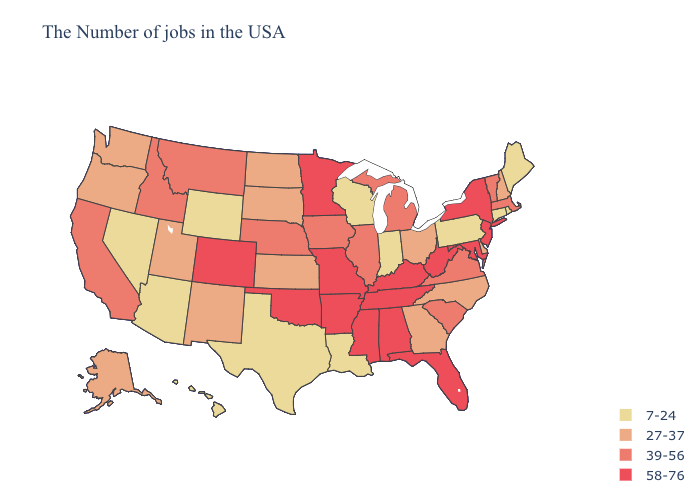Name the states that have a value in the range 27-37?
Answer briefly. New Hampshire, Delaware, North Carolina, Ohio, Georgia, Kansas, South Dakota, North Dakota, New Mexico, Utah, Washington, Oregon, Alaska. Which states hav the highest value in the MidWest?
Be succinct. Missouri, Minnesota. Name the states that have a value in the range 58-76?
Quick response, please. New York, New Jersey, Maryland, West Virginia, Florida, Kentucky, Alabama, Tennessee, Mississippi, Missouri, Arkansas, Minnesota, Oklahoma, Colorado. What is the highest value in states that border Georgia?
Quick response, please. 58-76. What is the value of Mississippi?
Concise answer only. 58-76. Name the states that have a value in the range 39-56?
Short answer required. Massachusetts, Vermont, Virginia, South Carolina, Michigan, Illinois, Iowa, Nebraska, Montana, Idaho, California. What is the value of Minnesota?
Keep it brief. 58-76. Name the states that have a value in the range 58-76?
Concise answer only. New York, New Jersey, Maryland, West Virginia, Florida, Kentucky, Alabama, Tennessee, Mississippi, Missouri, Arkansas, Minnesota, Oklahoma, Colorado. What is the highest value in the West ?
Quick response, please. 58-76. How many symbols are there in the legend?
Keep it brief. 4. What is the value of Delaware?
Concise answer only. 27-37. Does Florida have the highest value in the USA?
Concise answer only. Yes. What is the value of Minnesota?
Quick response, please. 58-76. Does the first symbol in the legend represent the smallest category?
Answer briefly. Yes. Which states have the highest value in the USA?
Be succinct. New York, New Jersey, Maryland, West Virginia, Florida, Kentucky, Alabama, Tennessee, Mississippi, Missouri, Arkansas, Minnesota, Oklahoma, Colorado. 